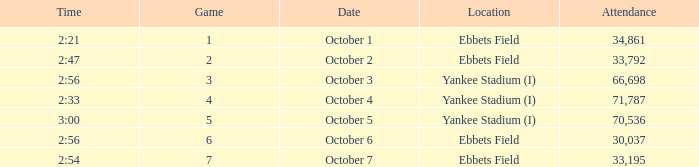Date of October 1 has what average game? 1.0. 